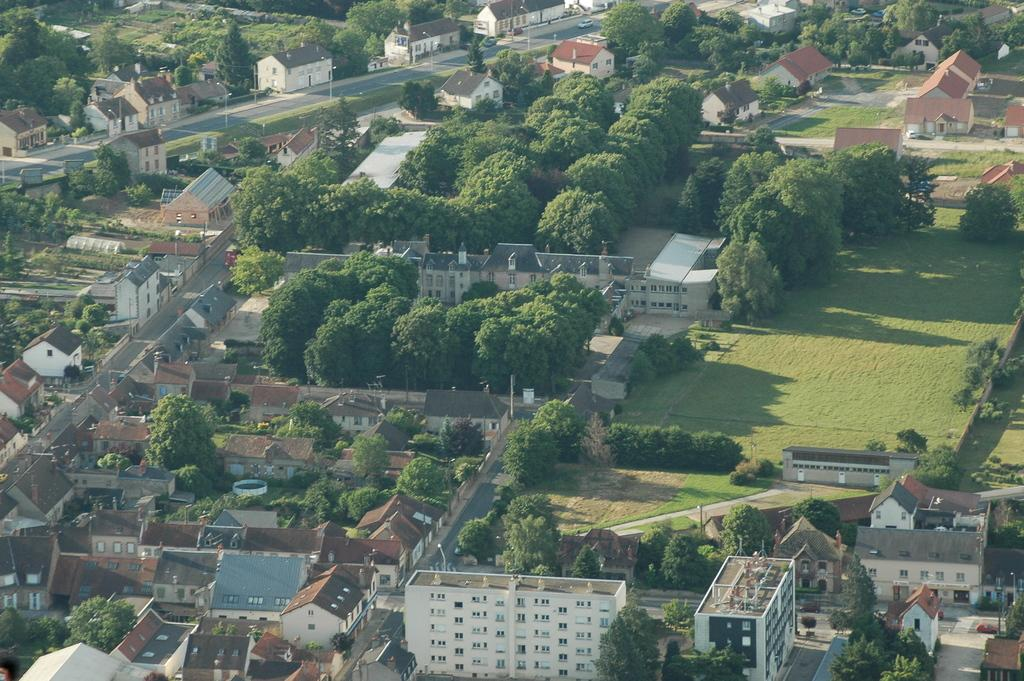What type of vegetation can be seen in the image? There are trees in the image. What type of structures are visible in the image? There are buildings in the image. What type of lighting is present in the image? Street lights are visible in the image. What type of pathway is present in the image? There is a road in the image. What type of transportation is present in the image? Vehicles are present in the image. What type of ground cover is visible in the image? Grass is observable in the image. Can you tell me how many geese are walking on the road in the image? There are no geese present in the image; it features trees, buildings, street lights, a road, and vehicles. What type of copy machine is visible in the image? There is no copy machine present in the image. 